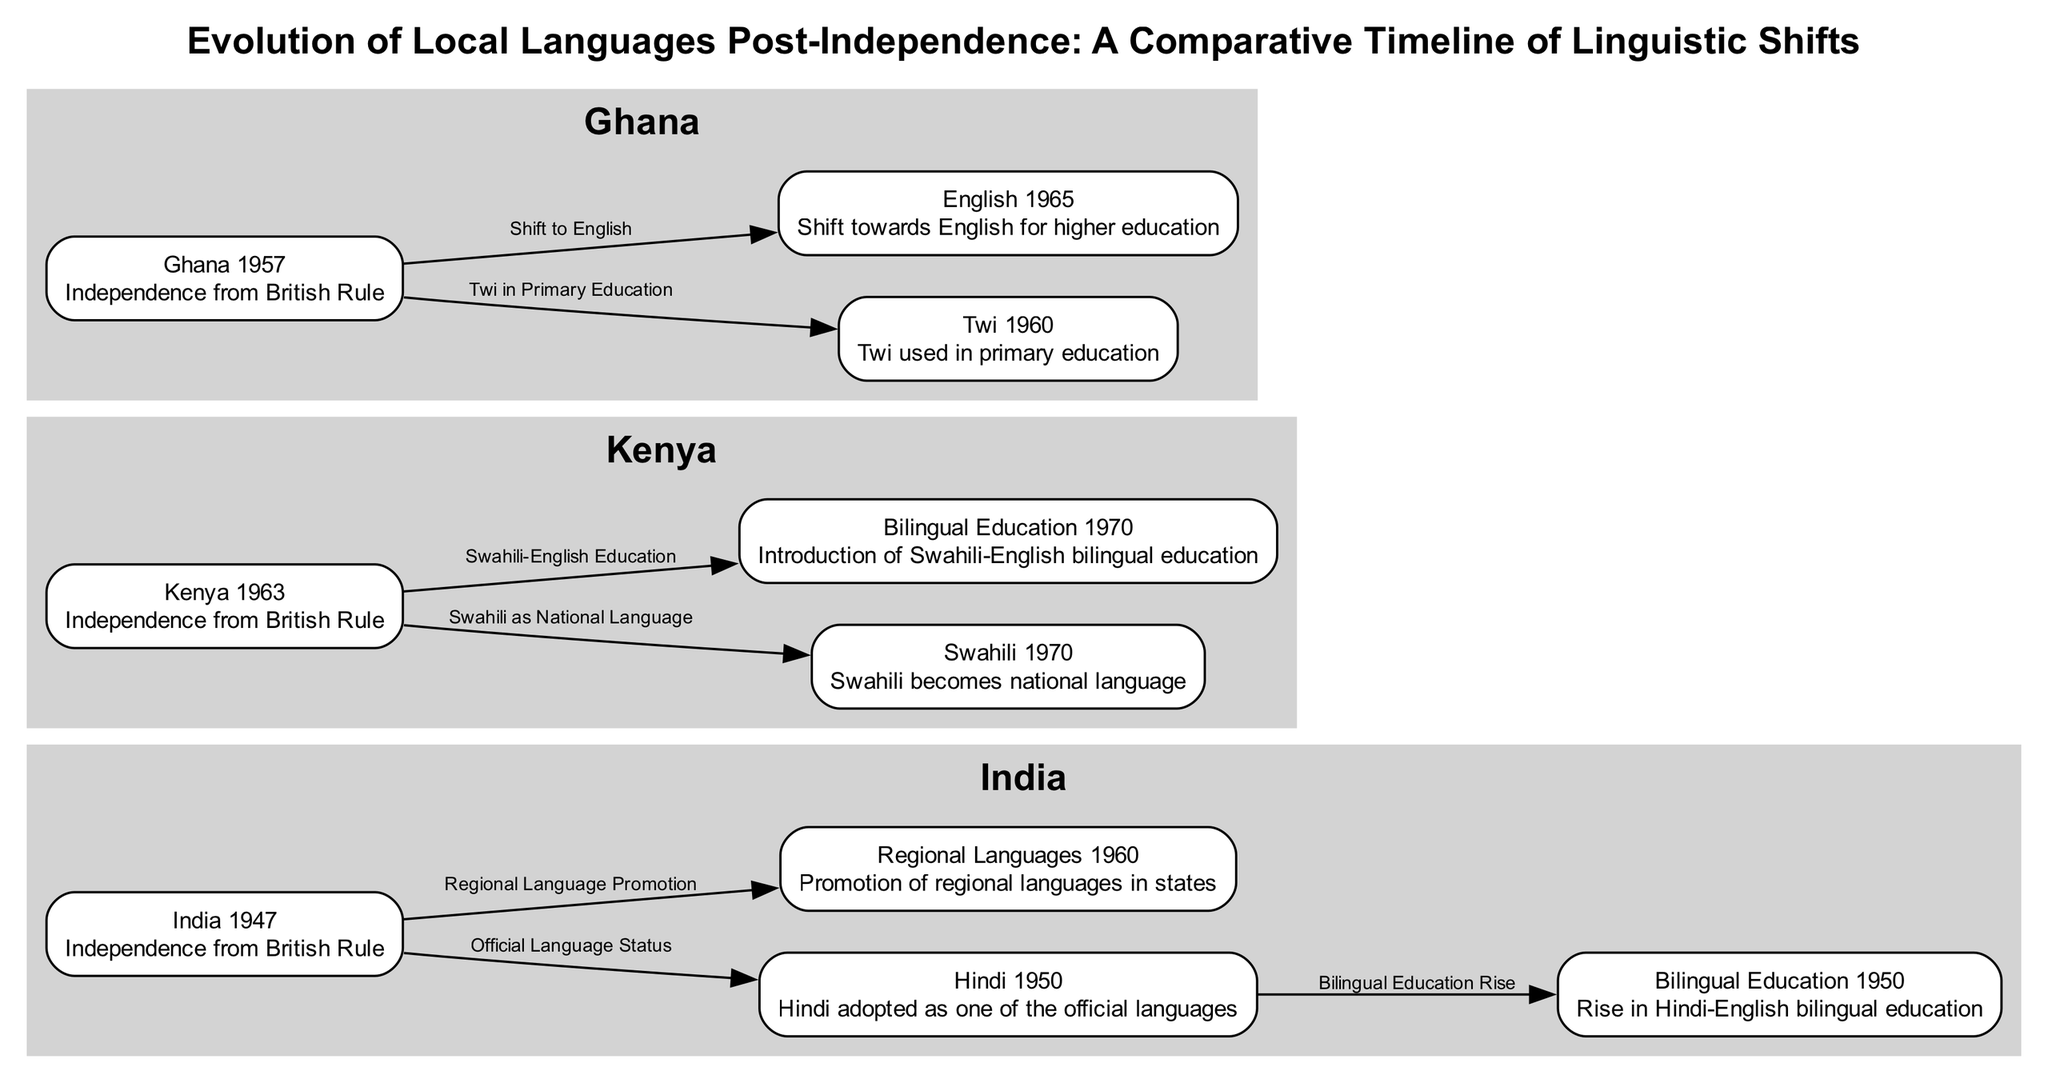What year did India gain independence? According to the diagram, India gained independence in 1947, which is represented as a node labeled "India 1947."
Answer: 1947 What is the official language adopted in India in 1950? The diagram shows a node labeled "Hindi 1950," indicating that Hindi was adopted as one of the official languages in India in that year.
Answer: Hindi How many nodes represent Ghana's linguistic evolution? Counting the relevant nodes in the diagram, there are three nodes for Ghana: "Ghana 1957," "Twi 1960," and "English 1965."
Answer: 3 What language became the national language of Kenya in 1970? Referring to the node labeled "Swahili 1970," it indicates that Swahili was established as the national language of Kenya.
Answer: Swahili What type of education rise was noted in India in 1950? The diagram features an edge from "Hindi 1950" to "Bilingual Education 1950," which indicates a rise in Hindi-English bilingual education that year.
Answer: Bilingual Education What landmark event occurs in Ghana in 1957? The node "Ghana 1957" marks the independence of Ghana from British rule, making it a significant event in that year.
Answer: Independence from British Rule What is the relationship between the nodes "Kenya 1963" and "Swahili 1970"? The edge connecting these nodes is labeled "Swahili as National Language," showing the progression from Kenya's independence to the establishment of Swahili as the national language.
Answer: Swahili as National Language Which educational shift occurred in Ghana by 1965? The edge from "Ghana 1957" to "English 1965" indicates a shift towards English being used for higher education in Ghana by that year.
Answer: Shift to English Name the first local language mentioned in the diagram after India's independence. The first local language mentioned is Hindi, which is reflected in the node "Hindi 1950" after India gained independence in 1947.
Answer: Hindi What common trend connects the countries represented in the diagram? The diagram showcases a trend of establishing local or indigenous languages as official or national languages following independence, reflecting a postcolonial focus on native languages.
Answer: Establishment of local languages 